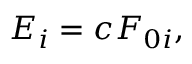<formula> <loc_0><loc_0><loc_500><loc_500>E _ { i } = c F _ { 0 i } ,</formula> 